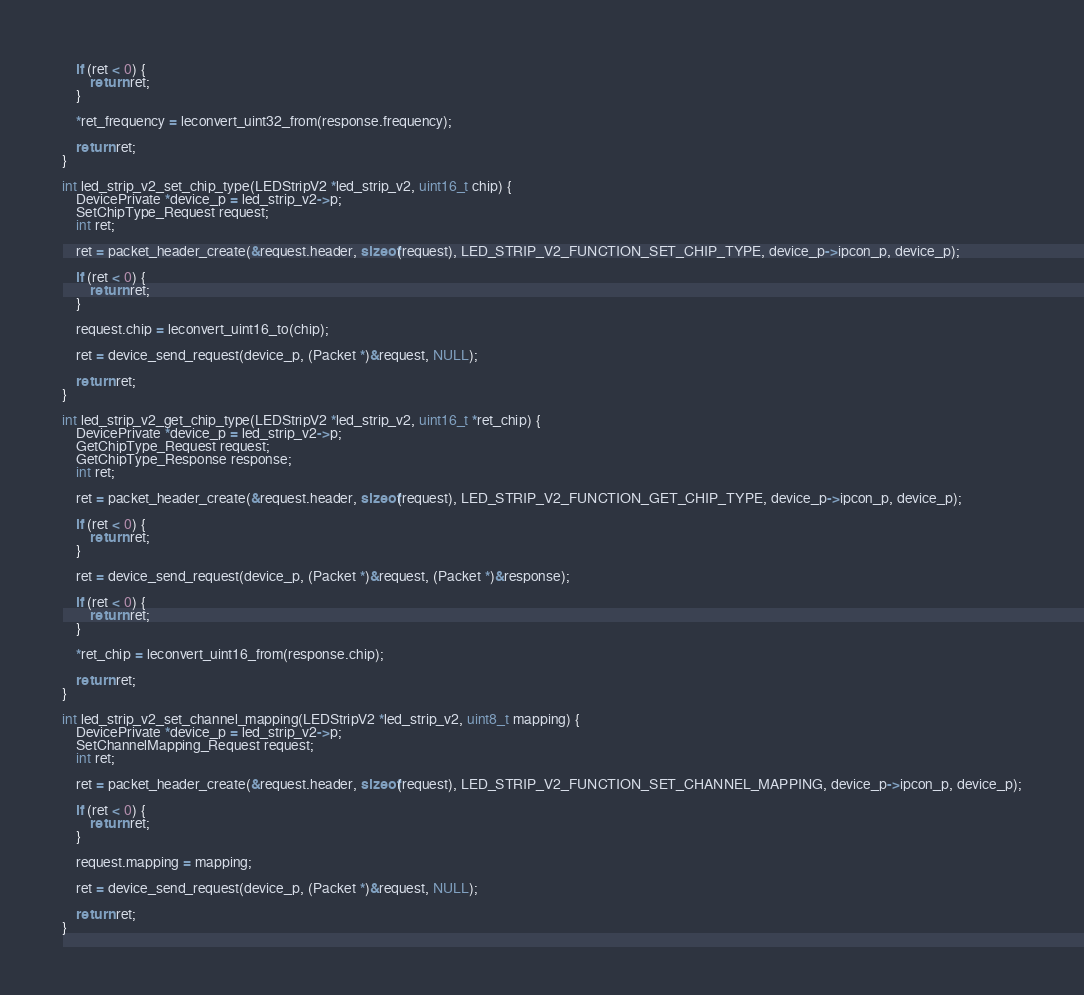Convert code to text. <code><loc_0><loc_0><loc_500><loc_500><_C_>
	if (ret < 0) {
		return ret;
	}

	*ret_frequency = leconvert_uint32_from(response.frequency);

	return ret;
}

int led_strip_v2_set_chip_type(LEDStripV2 *led_strip_v2, uint16_t chip) {
	DevicePrivate *device_p = led_strip_v2->p;
	SetChipType_Request request;
	int ret;

	ret = packet_header_create(&request.header, sizeof(request), LED_STRIP_V2_FUNCTION_SET_CHIP_TYPE, device_p->ipcon_p, device_p);

	if (ret < 0) {
		return ret;
	}

	request.chip = leconvert_uint16_to(chip);

	ret = device_send_request(device_p, (Packet *)&request, NULL);

	return ret;
}

int led_strip_v2_get_chip_type(LEDStripV2 *led_strip_v2, uint16_t *ret_chip) {
	DevicePrivate *device_p = led_strip_v2->p;
	GetChipType_Request request;
	GetChipType_Response response;
	int ret;

	ret = packet_header_create(&request.header, sizeof(request), LED_STRIP_V2_FUNCTION_GET_CHIP_TYPE, device_p->ipcon_p, device_p);

	if (ret < 0) {
		return ret;
	}

	ret = device_send_request(device_p, (Packet *)&request, (Packet *)&response);

	if (ret < 0) {
		return ret;
	}

	*ret_chip = leconvert_uint16_from(response.chip);

	return ret;
}

int led_strip_v2_set_channel_mapping(LEDStripV2 *led_strip_v2, uint8_t mapping) {
	DevicePrivate *device_p = led_strip_v2->p;
	SetChannelMapping_Request request;
	int ret;

	ret = packet_header_create(&request.header, sizeof(request), LED_STRIP_V2_FUNCTION_SET_CHANNEL_MAPPING, device_p->ipcon_p, device_p);

	if (ret < 0) {
		return ret;
	}

	request.mapping = mapping;

	ret = device_send_request(device_p, (Packet *)&request, NULL);

	return ret;
}
</code> 